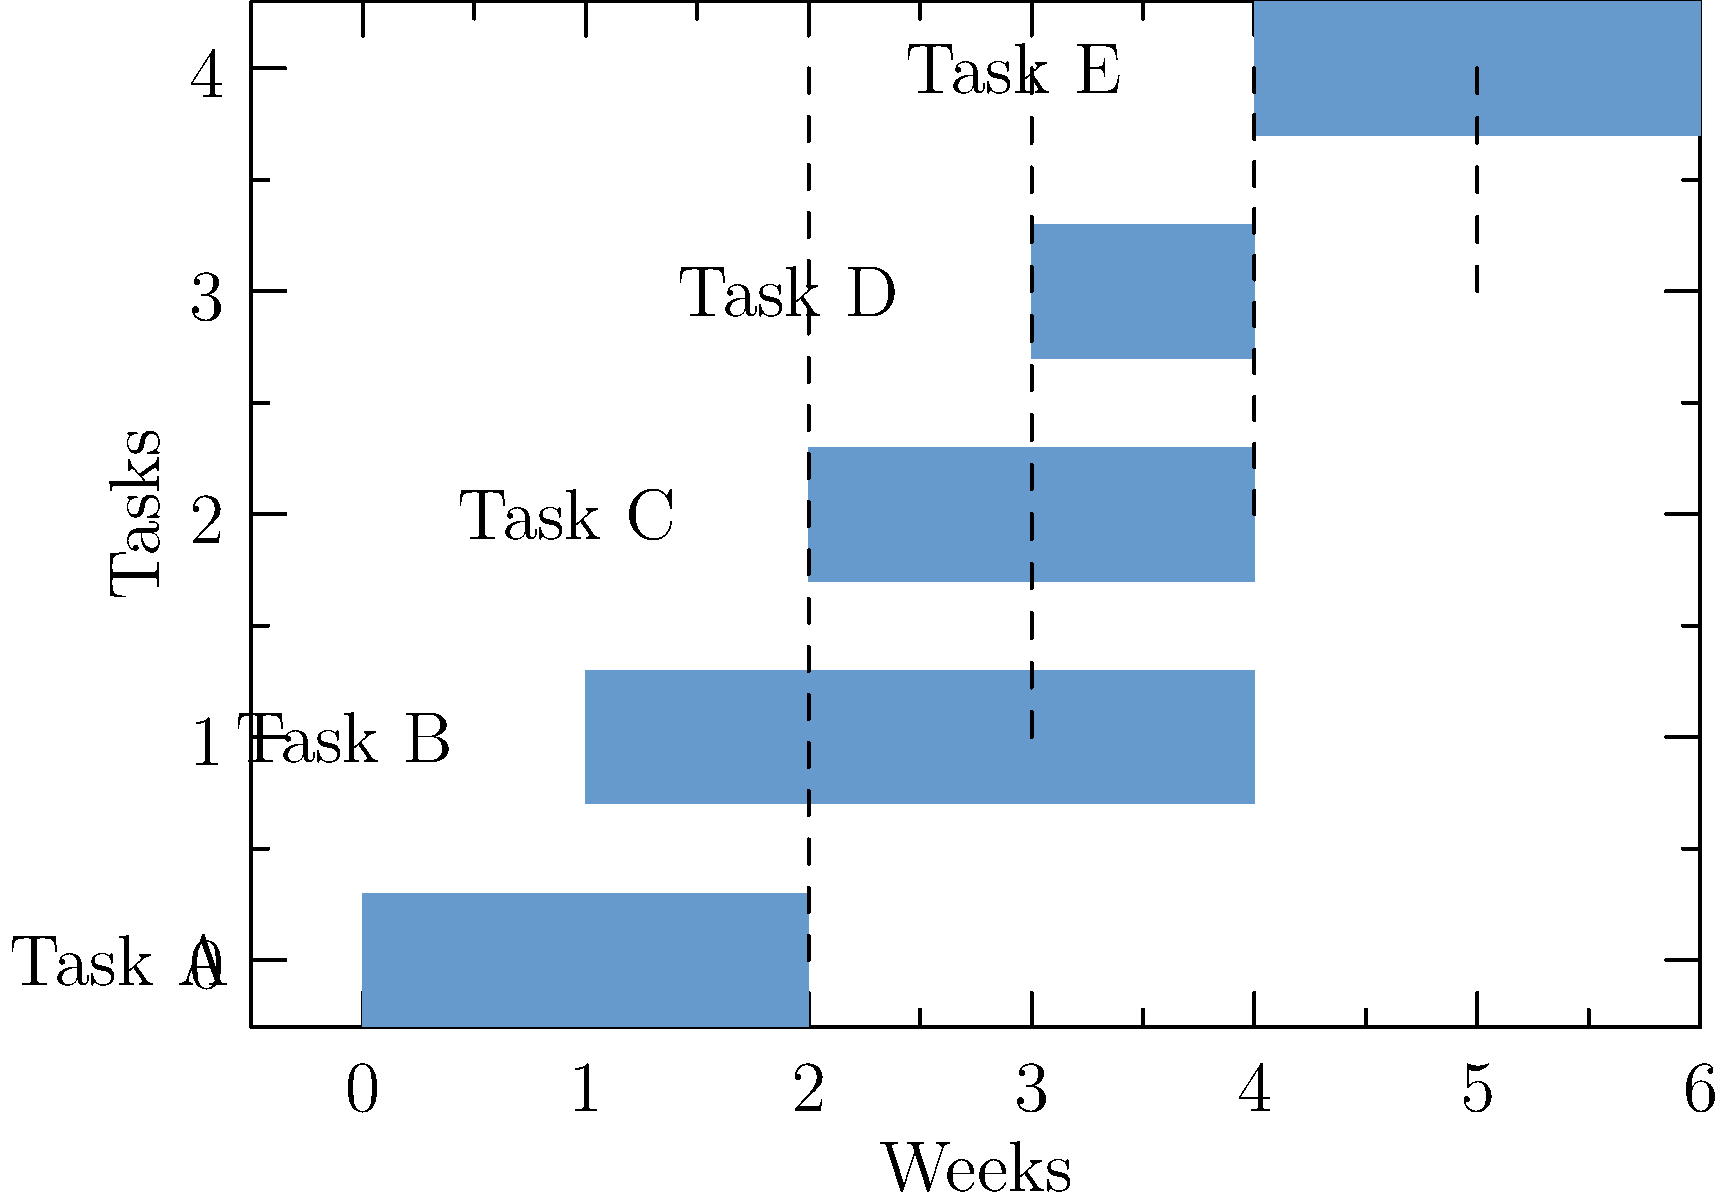Based on the Gantt chart provided, which task is on the critical path and must be completed on time to avoid delaying the entire project? To determine the critical path and identify the task that must be completed on time, let's analyze the Gantt chart step-by-step:

1. Observe the task dependencies:
   - Task B starts after Task A ends
   - Task C starts after Task B ends
   - Task D starts after Task C ends
   - Task E starts after Task D ends

2. Calculate the total project duration:
   - The project starts at week 0 and ends at week 6

3. Identify the critical path:
   - The critical path is the sequence of tasks that, if delayed, would delay the entire project
   - In this case, the critical path includes all tasks, as they are sequential

4. Analyze individual task durations:
   - Task A: 2 weeks
   - Task B: 3 weeks
   - Task C: 2 weeks
   - Task D: 1 week
   - Task E: 2 weeks

5. Identify the longest task:
   - Task B has the longest duration of 3 weeks

6. Consider the impact of delays:
   - If Task B is delayed, it will directly affect the start times of Tasks C, D, and E
   - A delay in Task B would have the most significant impact on the project timeline

Therefore, Task B is on the critical path and must be completed on time to avoid delaying the entire project.
Answer: Task B 